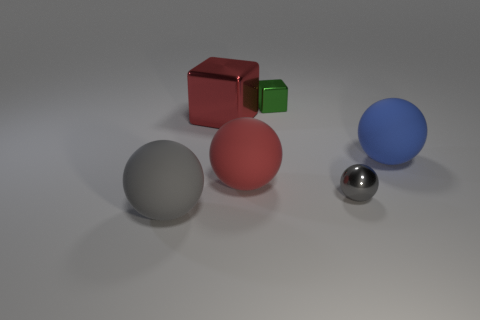What materials do the objects in the image seem to be made from? The objects in the image appear to be made from different materials. The spheres seem to have a matte finish with the gray one possibly made of stone or concrete, the red one resembling rubber, and the blue one suggesting a plastic material. The red cube looks metallic, perhaps painted aluminum, while the green cube has a reflective surface that could be either plastic or glass. The small silver sphere reflects the environment most clearly, suggesting it could be made of polished metal or chrome. 